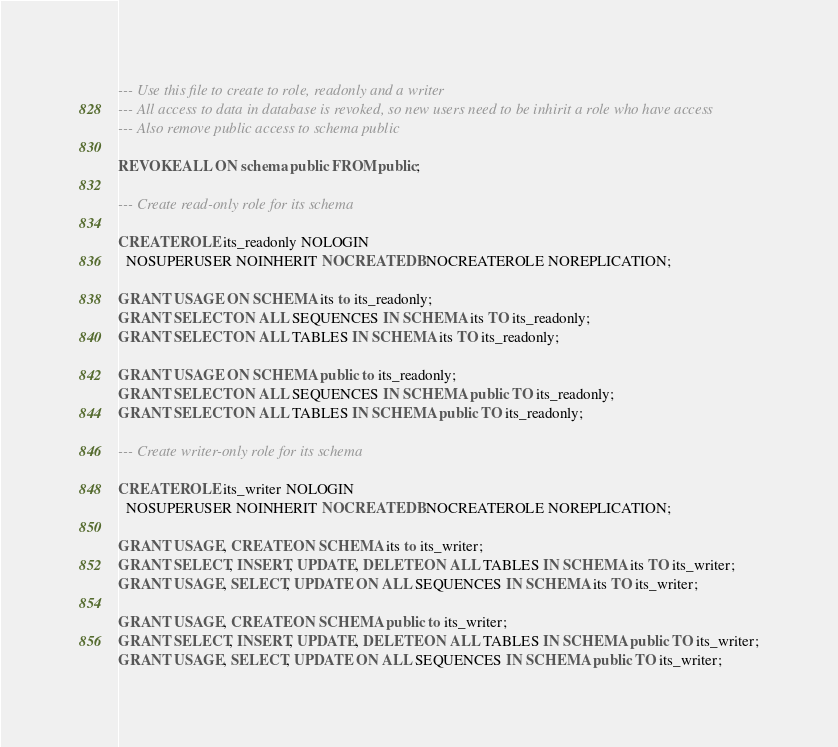Convert code to text. <code><loc_0><loc_0><loc_500><loc_500><_SQL_>--- Use this file to create to role, readonly and a writer
--- All access to data in database is revoked, so new users need to be inhirit a role who have access
--- Also remove public access to schema public

REVOKE ALL ON schema public FROM public;

--- Create read-only role for its schema

CREATE ROLE its_readonly NOLOGIN
  NOSUPERUSER NOINHERIT NOCREATEDB NOCREATEROLE NOREPLICATION;

GRANT USAGE ON SCHEMA its to its_readonly;
GRANT SELECT ON ALL SEQUENCES IN SCHEMA its TO its_readonly;
GRANT SELECT ON ALL TABLES IN SCHEMA its TO its_readonly;

GRANT USAGE ON SCHEMA public to its_readonly;
GRANT SELECT ON ALL SEQUENCES IN SCHEMA public TO its_readonly;
GRANT SELECT ON ALL TABLES IN SCHEMA public TO its_readonly;

--- Create writer-only role for its schema

CREATE ROLE its_writer NOLOGIN
  NOSUPERUSER NOINHERIT NOCREATEDB NOCREATEROLE NOREPLICATION;

GRANT USAGE, CREATE ON SCHEMA its to its_writer;
GRANT SELECT, INSERT, UPDATE, DELETE ON ALL TABLES IN SCHEMA its TO its_writer;
GRANT USAGE, SELECT, UPDATE ON ALL SEQUENCES IN SCHEMA its TO its_writer;

GRANT USAGE, CREATE ON SCHEMA public to its_writer;
GRANT SELECT, INSERT, UPDATE, DELETE ON ALL TABLES IN SCHEMA public TO its_writer;
GRANT USAGE, SELECT, UPDATE ON ALL SEQUENCES IN SCHEMA public TO its_writer;
</code> 